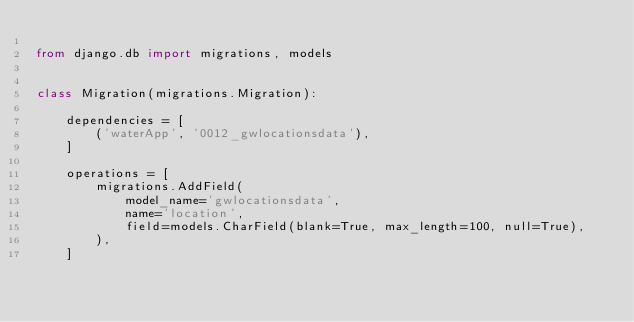<code> <loc_0><loc_0><loc_500><loc_500><_Python_>
from django.db import migrations, models


class Migration(migrations.Migration):

    dependencies = [
        ('waterApp', '0012_gwlocationsdata'),
    ]

    operations = [
        migrations.AddField(
            model_name='gwlocationsdata',
            name='location',
            field=models.CharField(blank=True, max_length=100, null=True),
        ),
    ]
</code> 